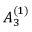Convert formula to latex. <formula><loc_0><loc_0><loc_500><loc_500>{ A } _ { 3 } ^ { ( 1 ) }</formula> 